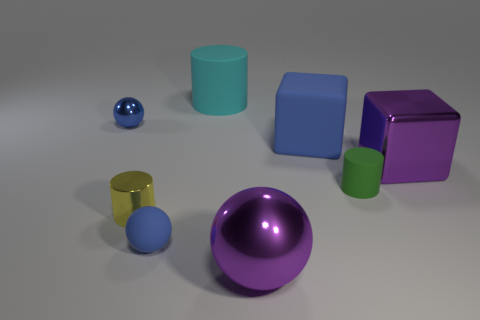Subtract all blue cylinders. How many blue spheres are left? 2 Subtract all tiny spheres. How many spheres are left? 1 Add 1 green rubber things. How many objects exist? 9 Subtract 1 spheres. How many spheres are left? 2 Subtract all purple balls. How many balls are left? 2 Subtract all cylinders. How many objects are left? 5 Add 7 large cylinders. How many large cylinders are left? 8 Add 1 small red metal blocks. How many small red metal blocks exist? 1 Subtract 0 gray spheres. How many objects are left? 8 Subtract all red cylinders. Subtract all purple balls. How many cylinders are left? 3 